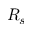Convert formula to latex. <formula><loc_0><loc_0><loc_500><loc_500>R _ { s }</formula> 